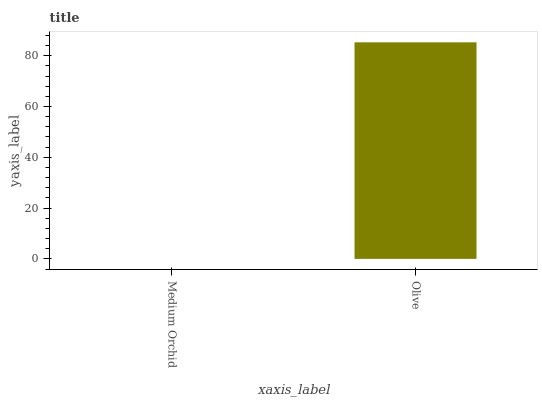Is Medium Orchid the minimum?
Answer yes or no. Yes. Is Olive the maximum?
Answer yes or no. Yes. Is Olive the minimum?
Answer yes or no. No. Is Olive greater than Medium Orchid?
Answer yes or no. Yes. Is Medium Orchid less than Olive?
Answer yes or no. Yes. Is Medium Orchid greater than Olive?
Answer yes or no. No. Is Olive less than Medium Orchid?
Answer yes or no. No. Is Olive the high median?
Answer yes or no. Yes. Is Medium Orchid the low median?
Answer yes or no. Yes. Is Medium Orchid the high median?
Answer yes or no. No. Is Olive the low median?
Answer yes or no. No. 